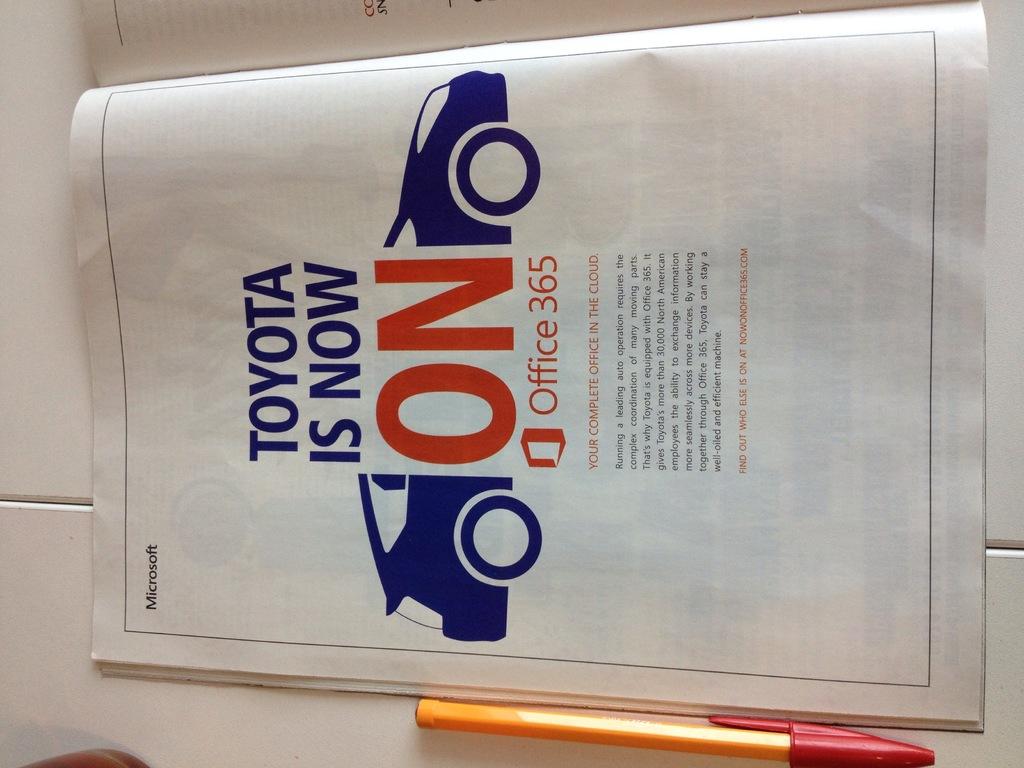What car brand is this?
Offer a very short reply. Toyota. What is toyota now on?
Give a very brief answer. Office 365. 